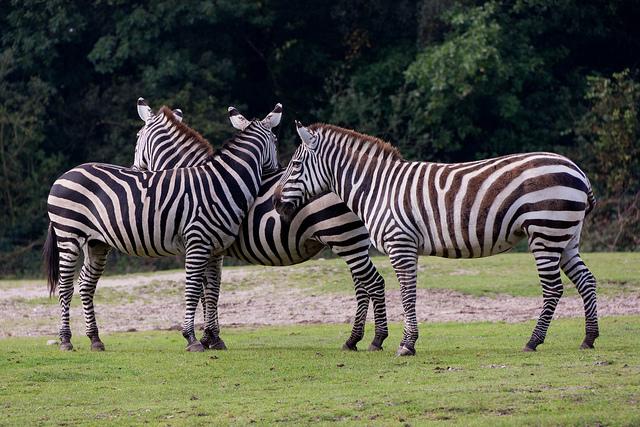Are the zebras fighting?
Short answer required. No. Is the zebra with a herd?
Quick response, please. Yes. IS there more than 1 zebra?
Short answer required. Yes. What kind of ground is the zebra walking on?
Write a very short answer. Grass. Are both of these zebras adult?
Keep it brief. Yes. How many animals are in this picture?
Quick response, please. 3. How many trees are in this image?
Quick response, please. 6. What is the animal on the far left of the picture doing?
Be succinct. Standing. How many zebras are visible?
Concise answer only. 3. Where is the zebra in the front looking?
Keep it brief. Left. How many zebras are here?
Keep it brief. 3. Are these wild animals?
Be succinct. Yes. Which way to the zebras' back leg joints face?
Short answer required. Right. What color are the zebra's stripes?
Keep it brief. Black and white. What is the likely relationship between the animals?
Short answer required. Family. Are the zebras standing on sand?
Keep it brief. No. How many zebras are there?
Quick response, please. 3. Is one of the zebras eating?
Write a very short answer. No. 